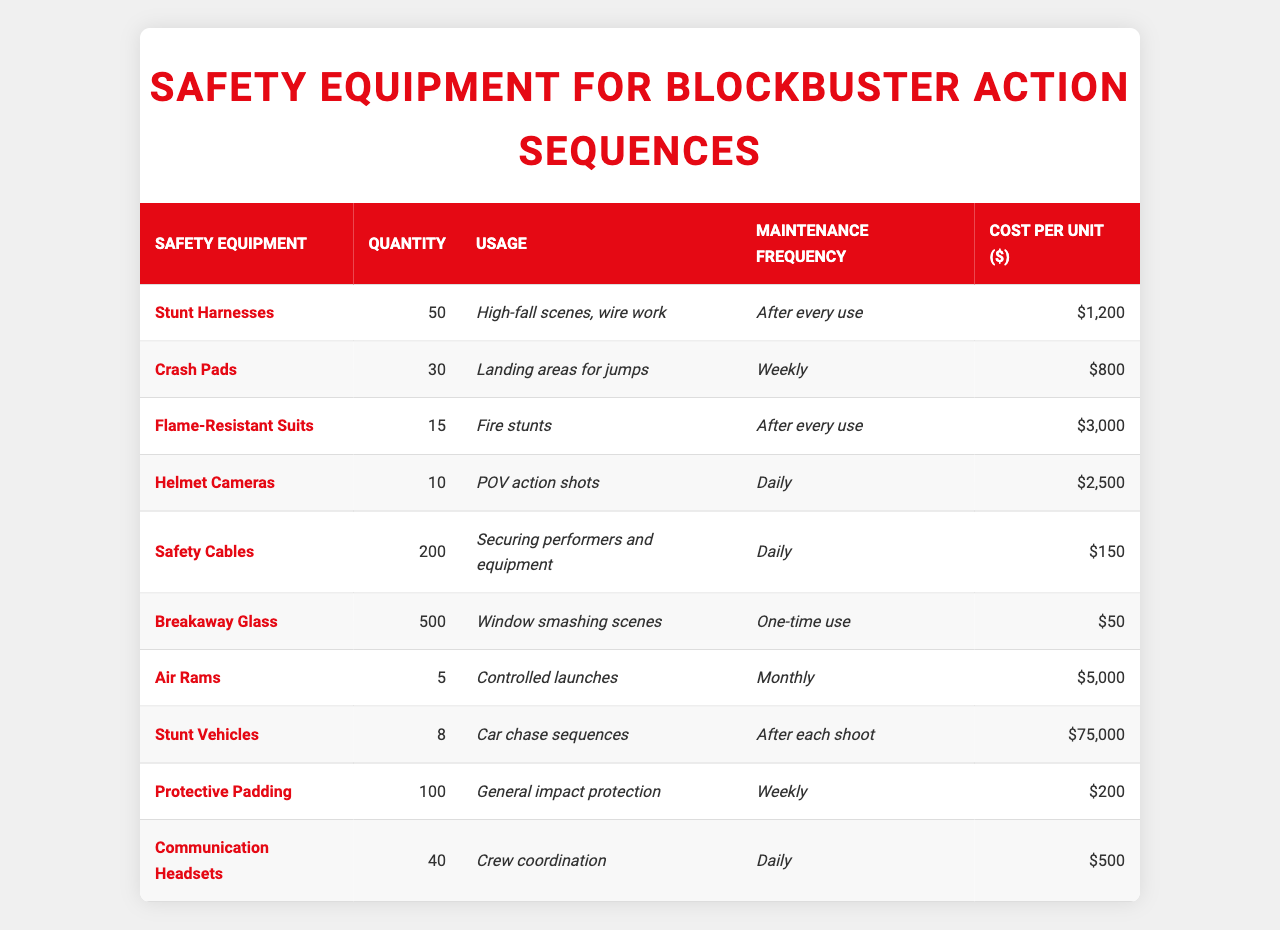What is the total quantity of safety equipment listed in the table? The total quantity can be found by summing all the values in the "Quantity" column: 50 + 30 + 15 + 10 + 200 + 500 + 5 + 8 + 100 + 40 = 958.
Answer: 958 Which safety equipment has the highest cost per unit? By examining the "Cost per Unit ($)" column, the highest value is for "Stunt Vehicles," which costs $75,000.
Answer: Stunt Vehicles How often are safety cables maintained? The maintenance frequency for safety cables is listed as "Daily."
Answer: Daily What is the total cost of all flame-resistant suits? To find the total cost, multiply the quantity (15) by the cost per unit ($3,000): 15 * 3000 = 45,000.
Answer: $45,000 Are communication headsets used in car chase sequences? Based on the "Usage" column, communication headsets are used for "Crew coordination," not specifically for car chase sequences.
Answer: No Calculate the average cost per unit of all safety equipment. The average cost can be calculated by summing all costs ($1,200 + $800 + $3,000 + $2,500 + $150 + $50 + $5,000 + $75,000 + $200 + $500) = $88,450 and then dividing by the number of equipment types (10): 88,450 / 10 = $8,845.
Answer: $8,845 How many types of safety equipment are used for fire stunts? The table shows that only "Flame-Resistant Suits" are used for fire stunts, making the total count 1.
Answer: 1 What percentage of the total quantity does breakaway glass represent? Breakaway glass has a quantity of 500. Total quantity is 958. The percentage is (500 / 958) * 100 = approximately 52.2%.
Answer: 52.2% Identify any equipment that requires maintenance less frequently than once a day. Equipment with less frequent maintenance includes "Crash Pads" and "Air Rams," which require maintenance on a weekly and monthly basis, respectively.
Answer: Crash Pads, Air Rams What is the total quantity of equipment used for securing performers and equipment? The "Safety Cables" represent the equipment used for securing, with a quantity of 200.
Answer: 200 